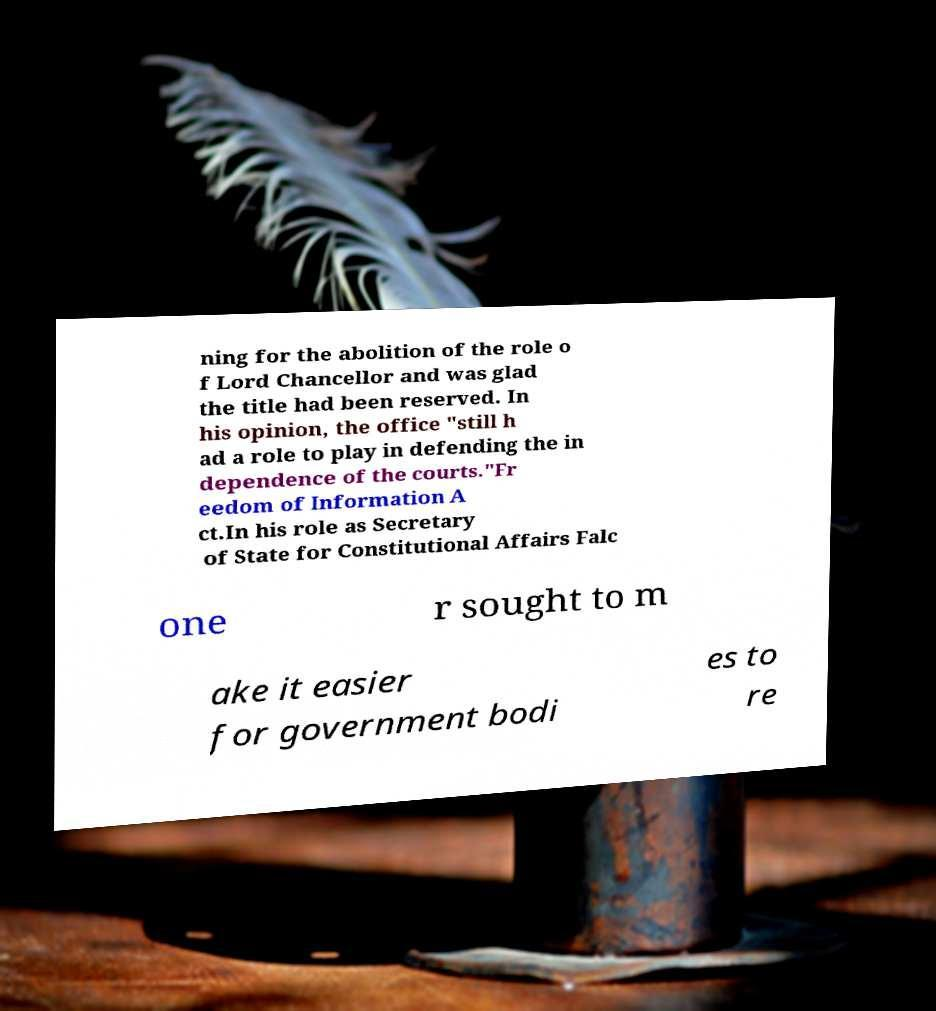Please identify and transcribe the text found in this image. ning for the abolition of the role o f Lord Chancellor and was glad the title had been reserved. In his opinion, the office "still h ad a role to play in defending the in dependence of the courts."Fr eedom of Information A ct.In his role as Secretary of State for Constitutional Affairs Falc one r sought to m ake it easier for government bodi es to re 